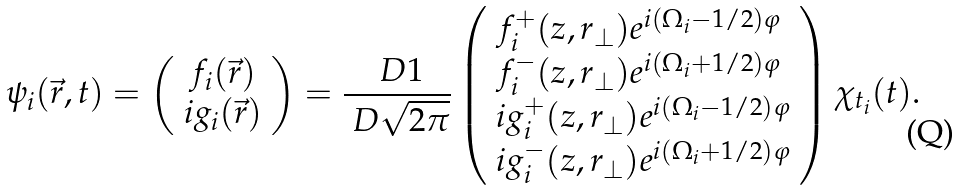<formula> <loc_0><loc_0><loc_500><loc_500>\psi _ { i } ( { \vec { r } } , t ) = \left ( \begin{array} { c } f _ { i } ( { \vec { r } } ) \\ i g _ { i } ( { \vec { r } } ) \end{array} \right ) = \frac { \ D 1 } { \ D \sqrt { 2 \pi } } \left ( \begin{array} { l } f ^ { + } _ { i } ( z , r _ { \bot } ) e ^ { i ( \Omega _ { i } - 1 / 2 ) \varphi } \\ f ^ { - } _ { i } ( z , r _ { \bot } ) e ^ { i ( \Omega _ { i } + 1 / 2 ) \varphi } \\ i g ^ { + } _ { i } ( z , r _ { \bot } ) e ^ { i ( \Omega _ { i } - 1 / 2 ) \varphi } \\ i g ^ { - } _ { i } ( z , r _ { \bot } ) e ^ { i ( \Omega _ { i } + 1 / 2 ) \varphi } \end{array} \right ) \chi _ { t _ { i } } ( t ) .</formula> 